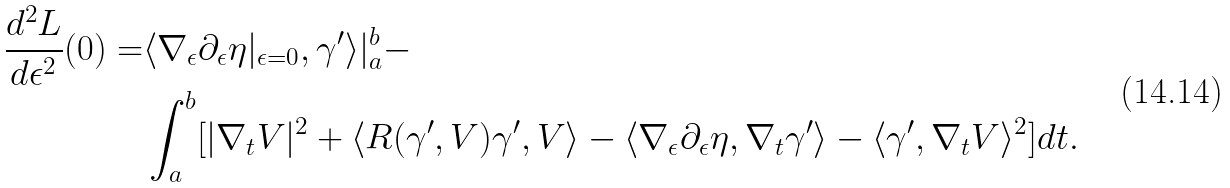<formula> <loc_0><loc_0><loc_500><loc_500>\frac { d ^ { 2 } L } { d \epsilon ^ { 2 } } ( 0 ) = & \langle \nabla _ { \epsilon } \partial _ { \epsilon } \eta | _ { \epsilon = 0 } , \gamma ^ { \prime } \rangle | _ { a } ^ { b } - \\ & \int _ { a } ^ { b } [ | \nabla _ { t } V | ^ { 2 } + \langle R ( \gamma ^ { \prime } , V ) \gamma ^ { \prime } , V \rangle - \langle \nabla _ { \epsilon } \partial _ { \epsilon } \eta , \nabla _ { t } \gamma ^ { \prime } \rangle - \langle \gamma ^ { \prime } , \nabla _ { t } V \rangle ^ { 2 } ] d t .</formula> 